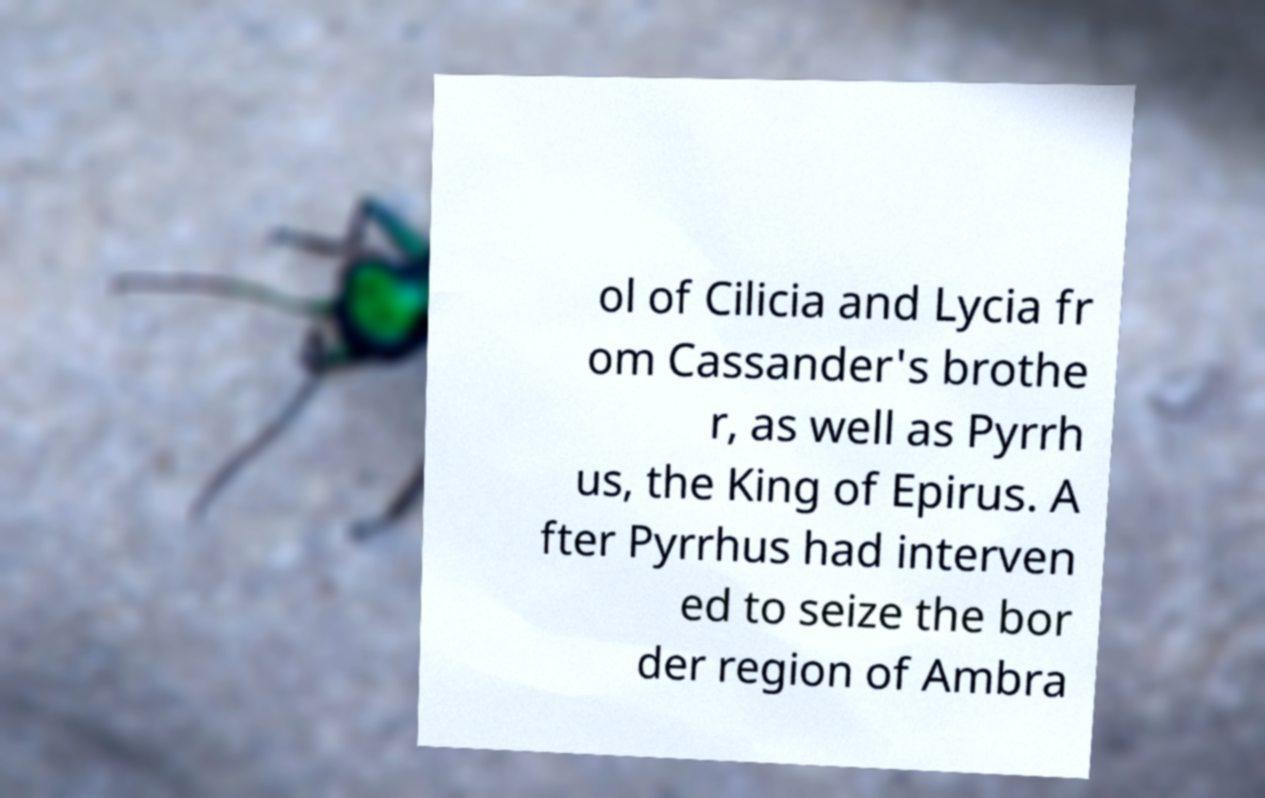Please read and relay the text visible in this image. What does it say? ol of Cilicia and Lycia fr om Cassander's brothe r, as well as Pyrrh us, the King of Epirus. A fter Pyrrhus had interven ed to seize the bor der region of Ambra 